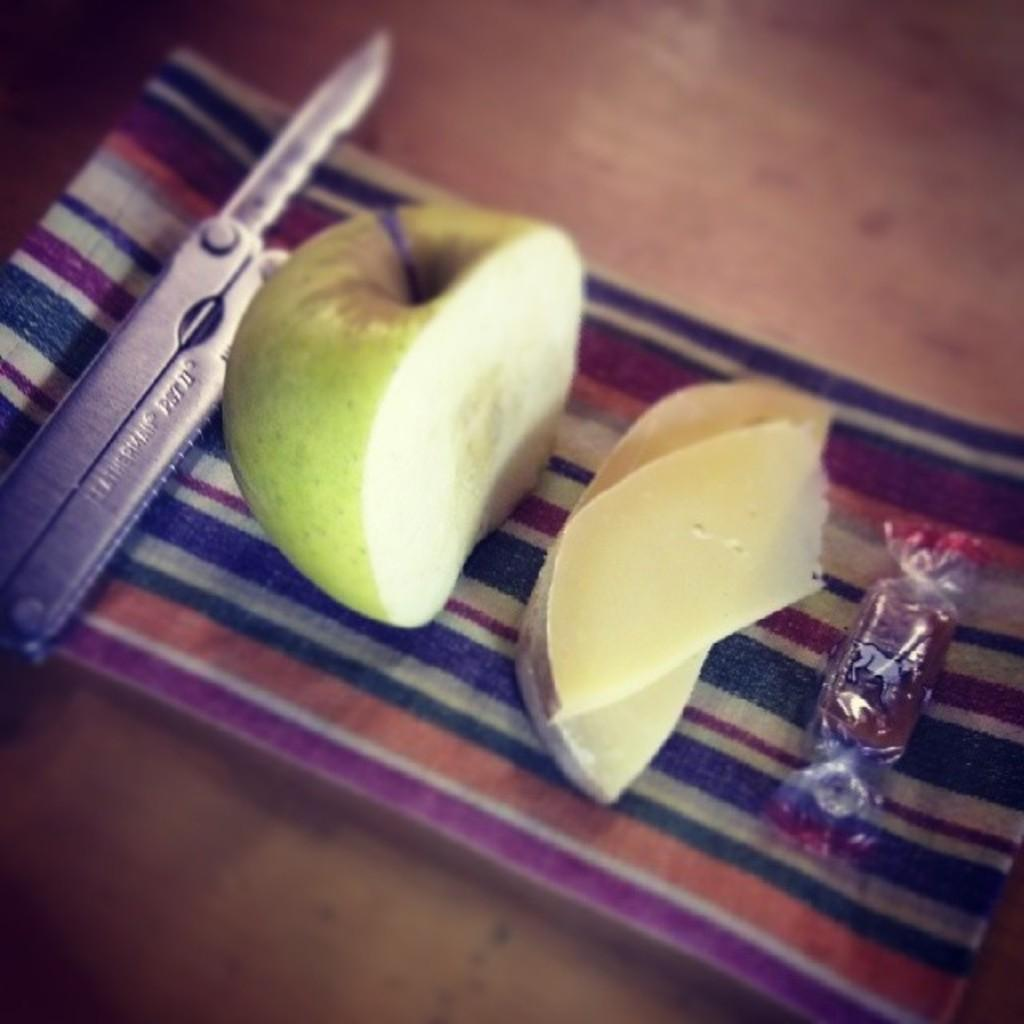What object is located on the left side of the image? There is a folding knife on the left side of the image. What is the main subject in the middle of the image? There is a green apple in the middle of the image. Can you describe the piece of apple in the image? There is a piece of apple in the image. What type of confectionery is on the right side of the image? There is a chocolate on the right side of the image. On what surface are all the items placed? All items are placed on a surface. What type of yarn is being used to create the folding knife in the image? There is no yarn present in the image, and the folding knife is not made of yarn. Is there a laborer in the image working with the green apple? There is no laborer present in the image; it only features a green apple, a piece of apple, a folding knife, and a chocolate. 